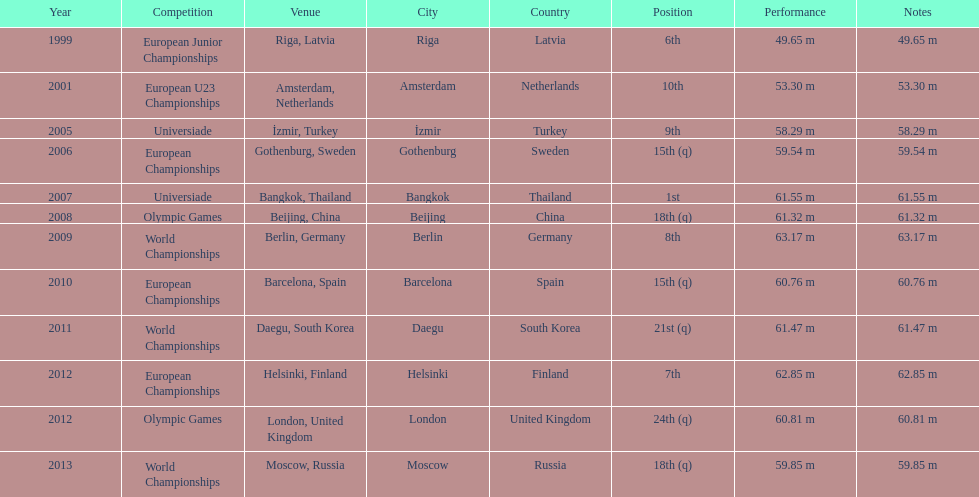Name two events in which mayer competed before he won the bangkok universiade. European Championships, Universiade. 